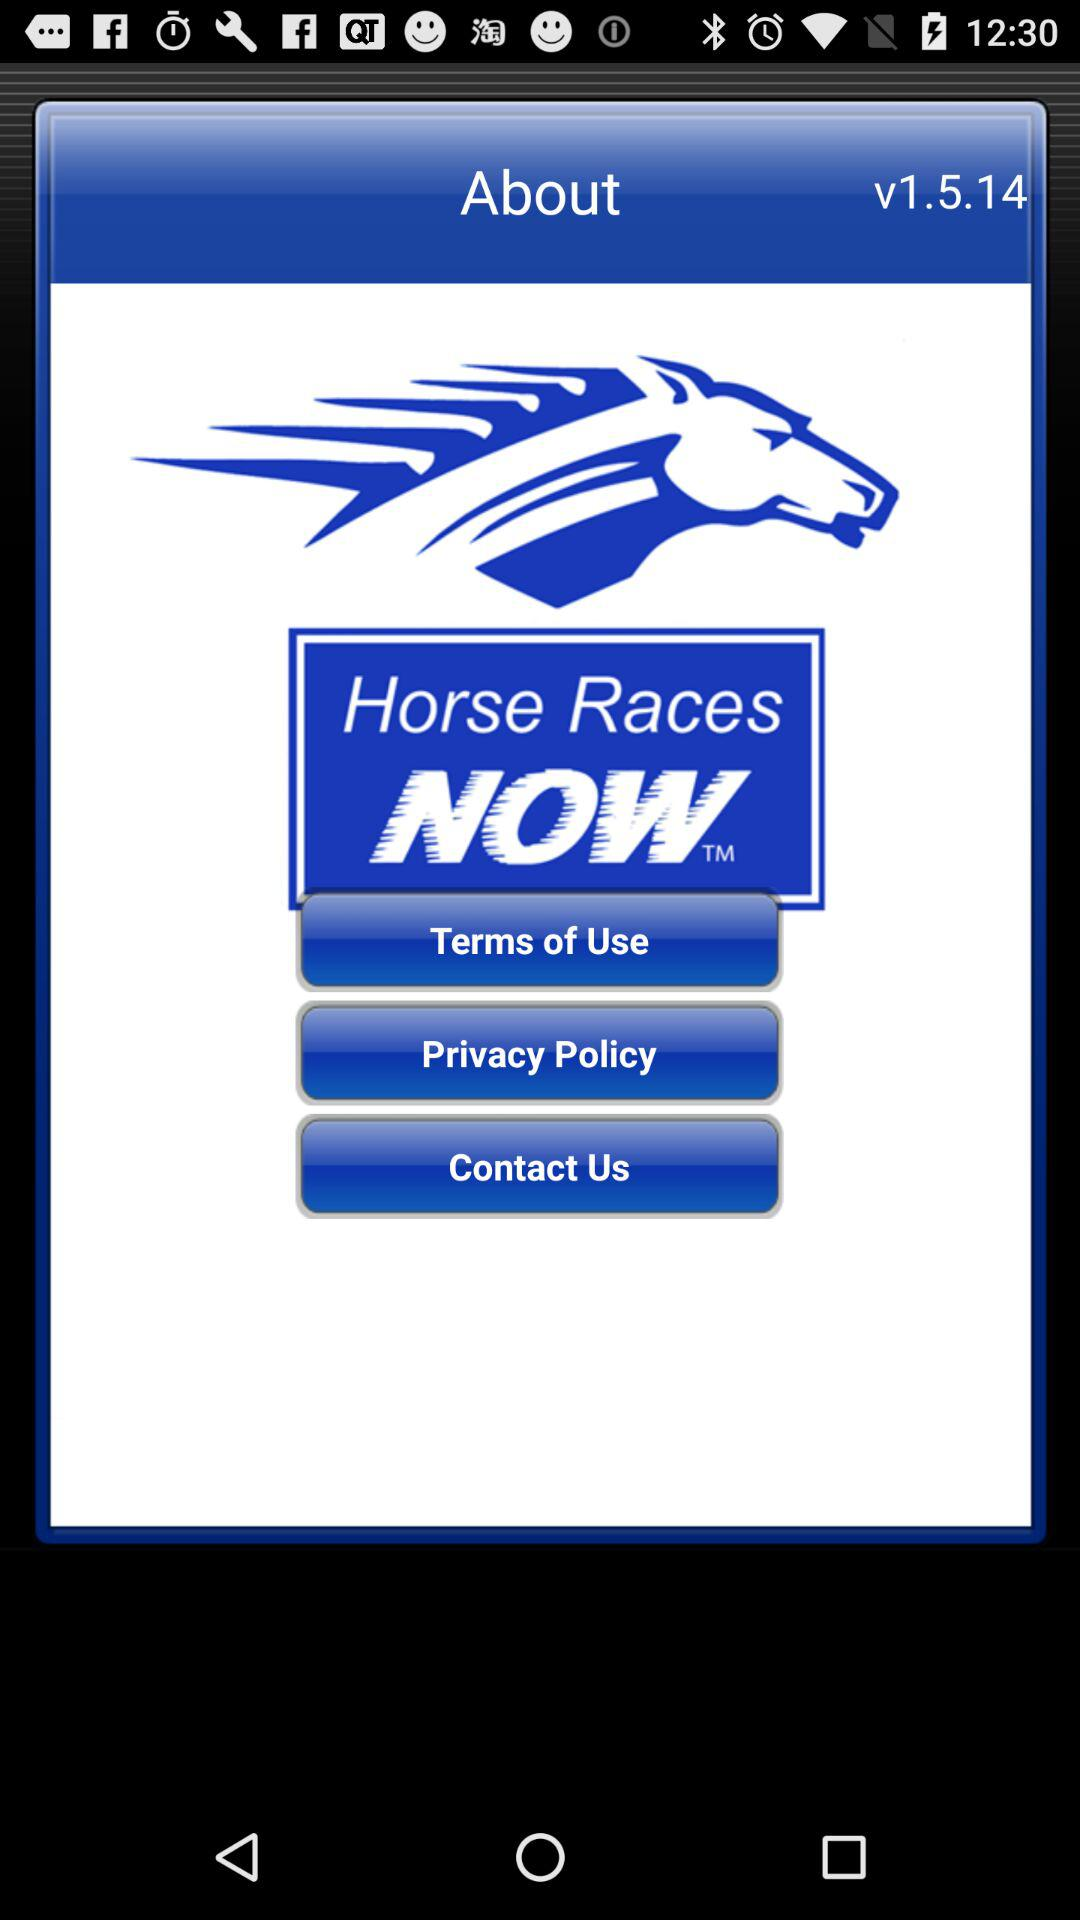What is the version number? The version number is v1.5.14. 